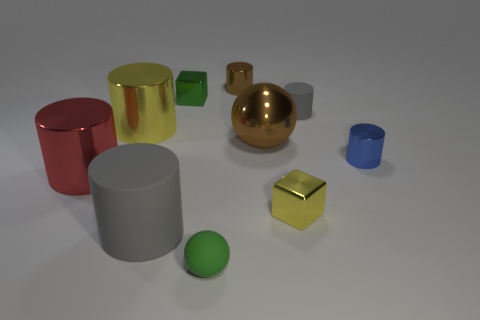Subtract all tiny rubber cylinders. How many cylinders are left? 5 Subtract all purple spheres. How many gray cylinders are left? 2 Subtract 1 cylinders. How many cylinders are left? 5 Subtract all gray cylinders. How many cylinders are left? 4 Subtract all purple cylinders. Subtract all cyan balls. How many cylinders are left? 6 Subtract all cubes. How many objects are left? 8 Subtract all small green spheres. Subtract all large yellow cylinders. How many objects are left? 8 Add 7 big matte cylinders. How many big matte cylinders are left? 8 Add 6 big brown things. How many big brown things exist? 7 Subtract 1 blue cylinders. How many objects are left? 9 